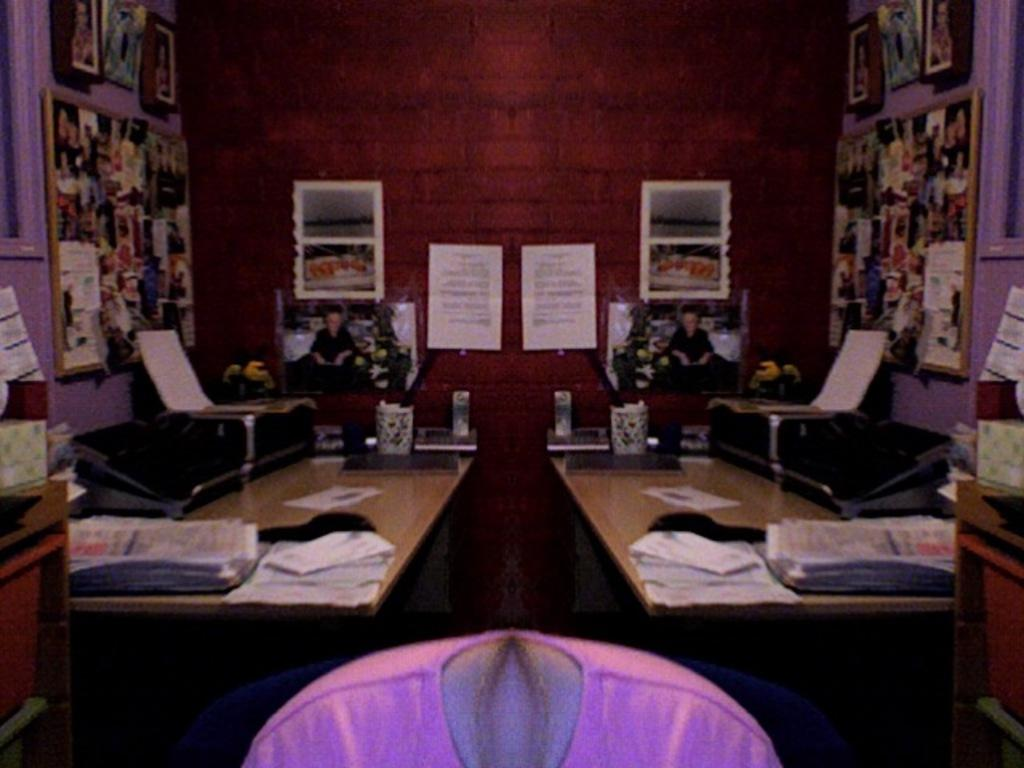What type of furniture is present in the image? There are wooden tables in the image. What is placed on the wooden tables? The wooden tables have objects on them. What can be seen in the background of the image? There are walls in the background of the image. What is attached to the walls? The walls have photos, boards, papers, and other objects attached to them. How does the image make you care about the fact that people laugh? The image does not make you care about any facts or emotions related to laughter, as it only shows wooden tables, objects on the tables, and walls with various attachments. 